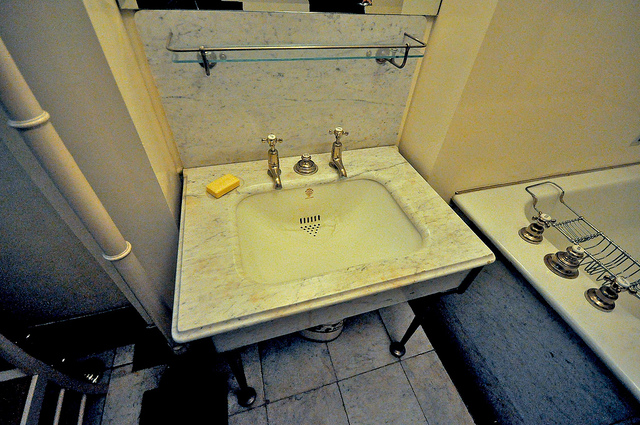Where is the soap located? The soap is located on the marble countertop, positioned to the left side of the sink. 